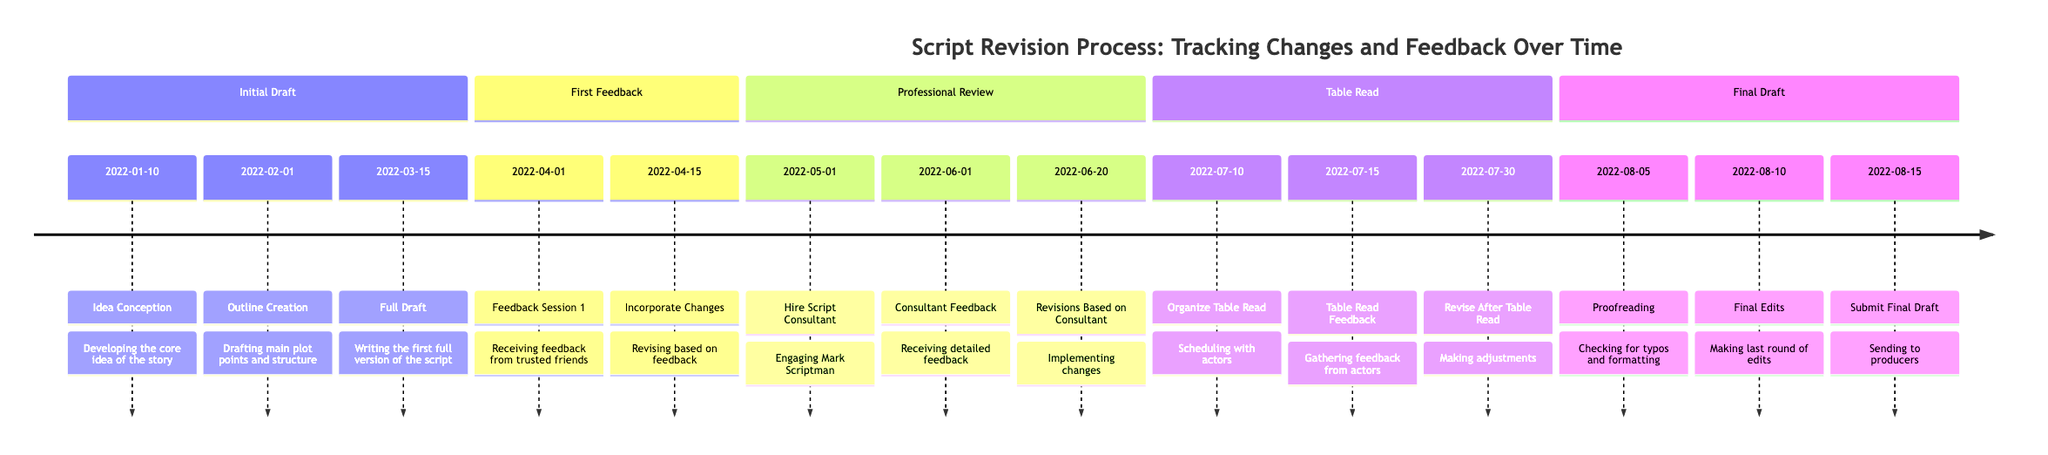What is the first milestone in the Initial Draft phase? The first milestone listed under the Initial Draft phase is "Idea Conception," which is the development of the core idea of the story.
Answer: Idea Conception How many milestones are in the Final Draft phase? There are three milestones listed under the Final Draft phase: Proofreading, Final Edits, and Submit Final Draft.
Answer: 3 Who provided feedback during the first feedback session? The participants in the Feedback Session 1 are Anna, John, and Maria, as stated in the timeline.
Answer: Anna, John, Maria What date was the Full Draft completed? The Full Draft was completed on March 15, 2022, as specified in the timeline.
Answer: 2022-03-15 Which milestone comes after the Consultant Feedback? The milestone that comes after Consultant Feedback is "Revisions Based on Consultant," scheduled for June 20, 2022.
Answer: Revisions Based on Consultant How many phases are there in the overall timeline? There are five phases included in the timeline: Initial Draft, First Feedback, Professional Review, Table Read, and Final Draft.
Answer: 5 What action was taken on April 15, 2022? On April 15, 2022, the action "Incorporate Changes" took place, which means making revisions based on the feedback received.
Answer: Incorporate Changes When was the table read organized? The table read was organized on July 10, 2022, according to the timeline details.
Answer: 2022-07-10 What is the last milestone before submitting the final draft? The last milestone before submitting the final draft is "Final Edits," which occurs on August 10, 2022.
Answer: Final Edits 